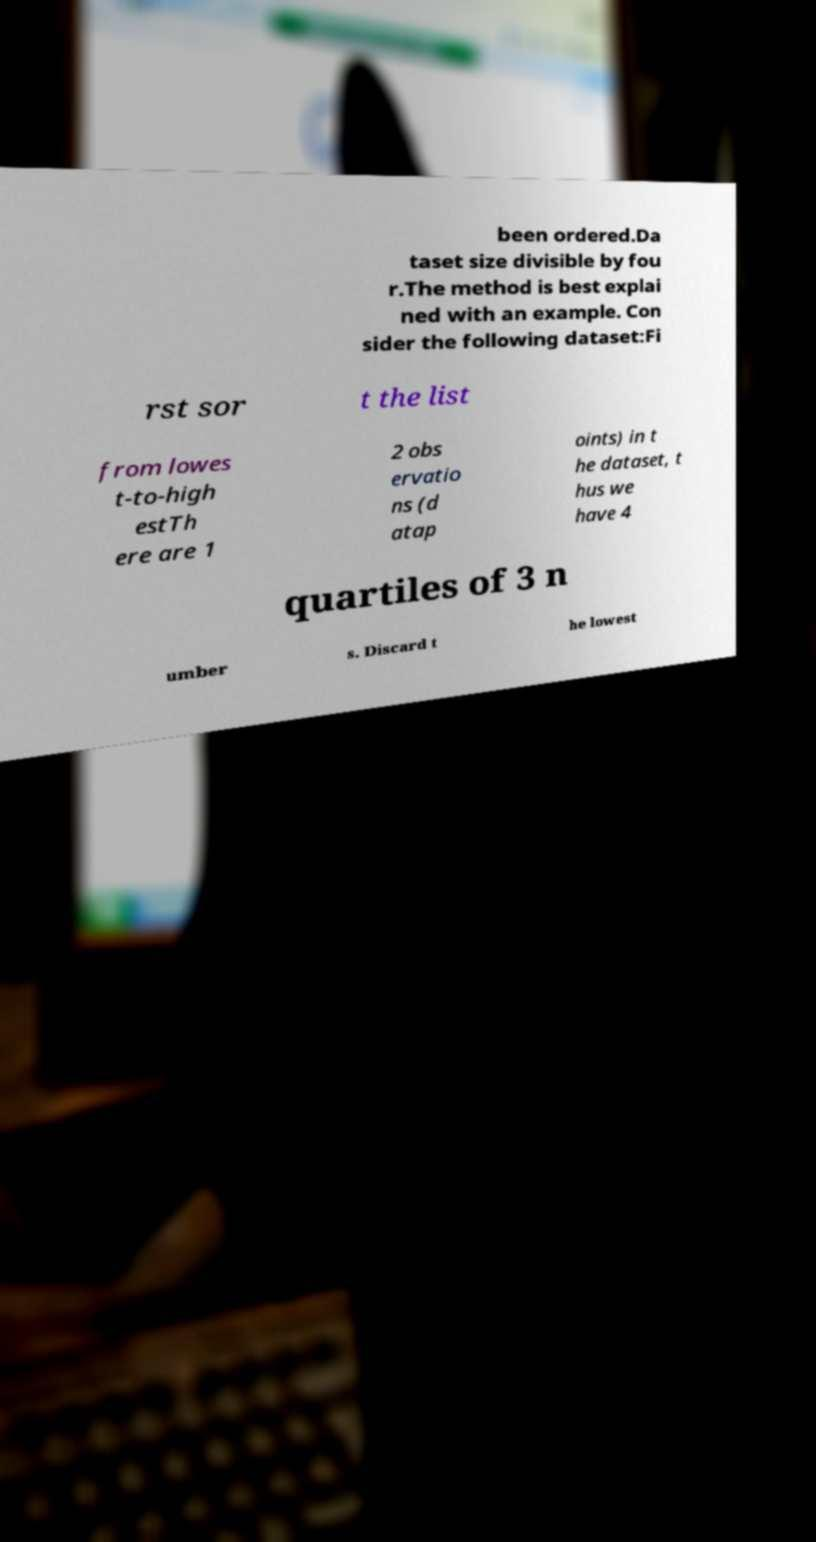Could you extract and type out the text from this image? been ordered.Da taset size divisible by fou r.The method is best explai ned with an example. Con sider the following dataset:Fi rst sor t the list from lowes t-to-high estTh ere are 1 2 obs ervatio ns (d atap oints) in t he dataset, t hus we have 4 quartiles of 3 n umber s. Discard t he lowest 